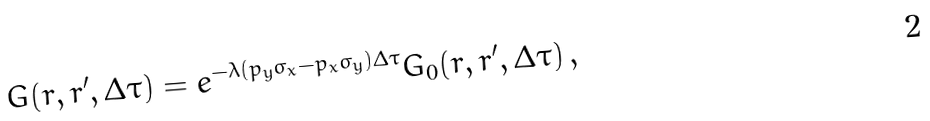<formula> <loc_0><loc_0><loc_500><loc_500>G ( r , r ^ { \prime } , \Delta \tau ) = e ^ { - \lambda ( p _ { y } \sigma _ { x } - p _ { x } \sigma _ { y } ) \Delta \tau } G _ { 0 } ( r , r ^ { \prime } , \Delta \tau ) \, ,</formula> 